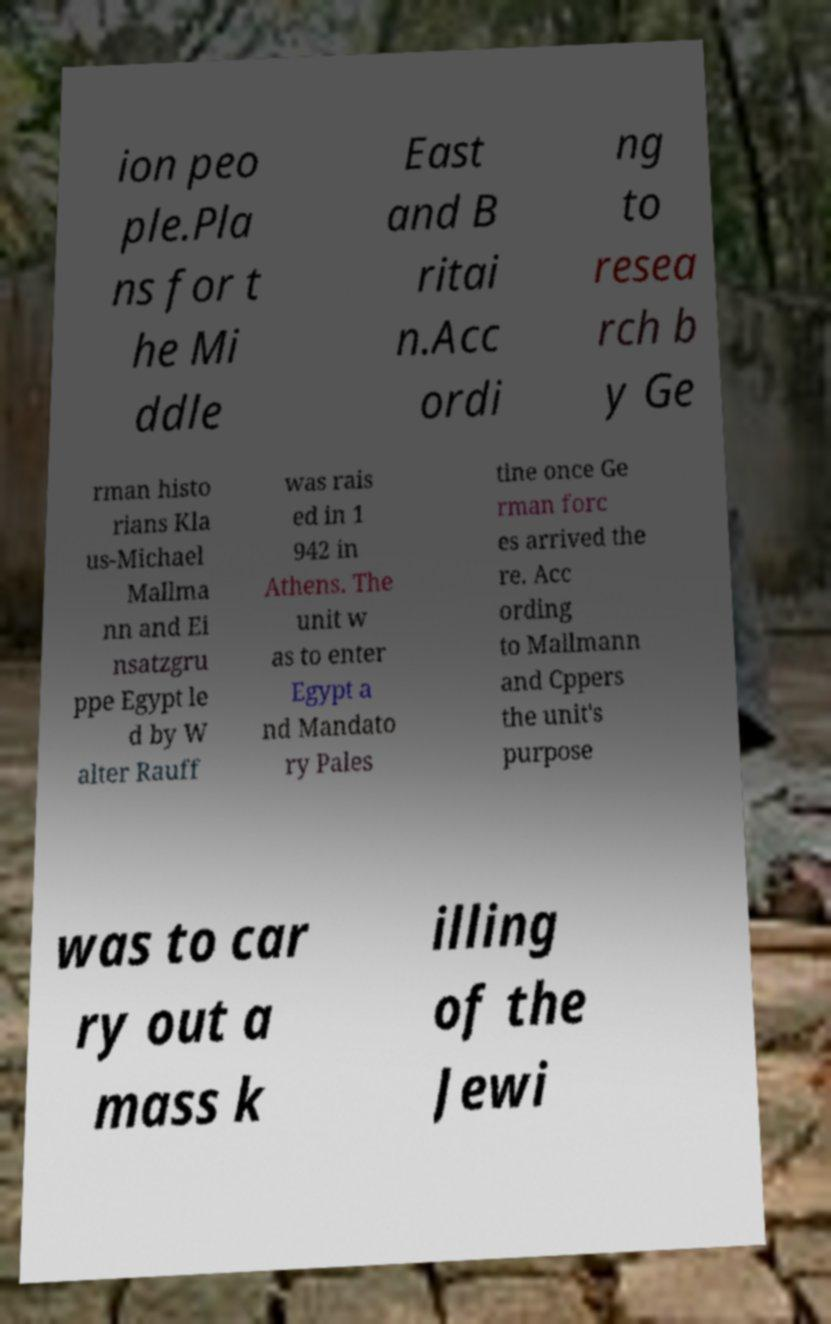I need the written content from this picture converted into text. Can you do that? ion peo ple.Pla ns for t he Mi ddle East and B ritai n.Acc ordi ng to resea rch b y Ge rman histo rians Kla us-Michael Mallma nn and Ei nsatzgru ppe Egypt le d by W alter Rauff was rais ed in 1 942 in Athens. The unit w as to enter Egypt a nd Mandato ry Pales tine once Ge rman forc es arrived the re. Acc ording to Mallmann and Cppers the unit's purpose was to car ry out a mass k illing of the Jewi 